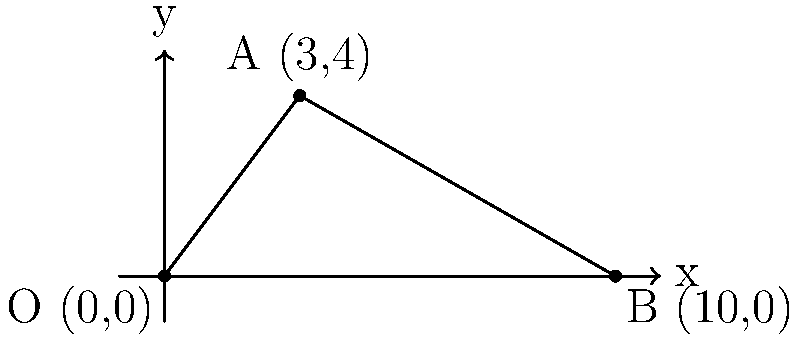In a soccer match, you're positioned at point A (3,4) on the field, represented by a coordinate system where each unit equals 1 meter. The goal post is located at point B (10,0). If you take a shot towards the goal post, what is the angle (in degrees) between your shot and the ground? To solve this problem, we'll use the concept of inverse tangent (arctan) in a right-angled triangle. Here's the step-by-step solution:

1) First, we need to find the height and base of the right-angled triangle formed by the shot:
   - Height (y-coordinate difference) = $4 - 0 = 4$ meters
   - Base (x-coordinate difference) = $10 - 3 = 7$ meters

2) The angle we're looking for is the one formed between the hypotenuse (the shot) and the base (parallel to the ground).

3) We can calculate this angle using the inverse tangent function:
   $\theta = \tan^{-1}(\frac{\text{opposite}}{\text{adjacent}}) = \tan^{-1}(\frac{\text{height}}{\text{base}})$

4) Plugging in our values:
   $\theta = \tan^{-1}(\frac{4}{7})$

5) Using a calculator or computer:
   $\theta \approx 29.7449$ degrees

6) Rounding to two decimal places:
   $\theta \approx 29.74$ degrees

Therefore, the angle between your shot and the ground is approximately 29.74 degrees.
Answer: $29.74^\circ$ 